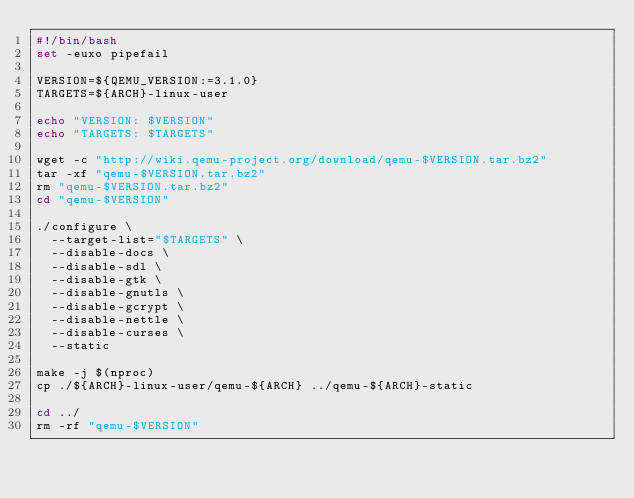<code> <loc_0><loc_0><loc_500><loc_500><_Bash_>#!/bin/bash
set -euxo pipefail

VERSION=${QEMU_VERSION:=3.1.0}
TARGETS=${ARCH}-linux-user

echo "VERSION: $VERSION"
echo "TARGETS: $TARGETS"

wget -c "http://wiki.qemu-project.org/download/qemu-$VERSION.tar.bz2"
tar -xf "qemu-$VERSION.tar.bz2"
rm "qemu-$VERSION.tar.bz2"
cd "qemu-$VERSION"

./configure \
  --target-list="$TARGETS" \
  --disable-docs \
  --disable-sdl \
  --disable-gtk \
  --disable-gnutls \
  --disable-gcrypt \
  --disable-nettle \
  --disable-curses \
  --static

make -j $(nproc)
cp ./${ARCH}-linux-user/qemu-${ARCH} ../qemu-${ARCH}-static

cd ../
rm -rf "qemu-$VERSION"
</code> 